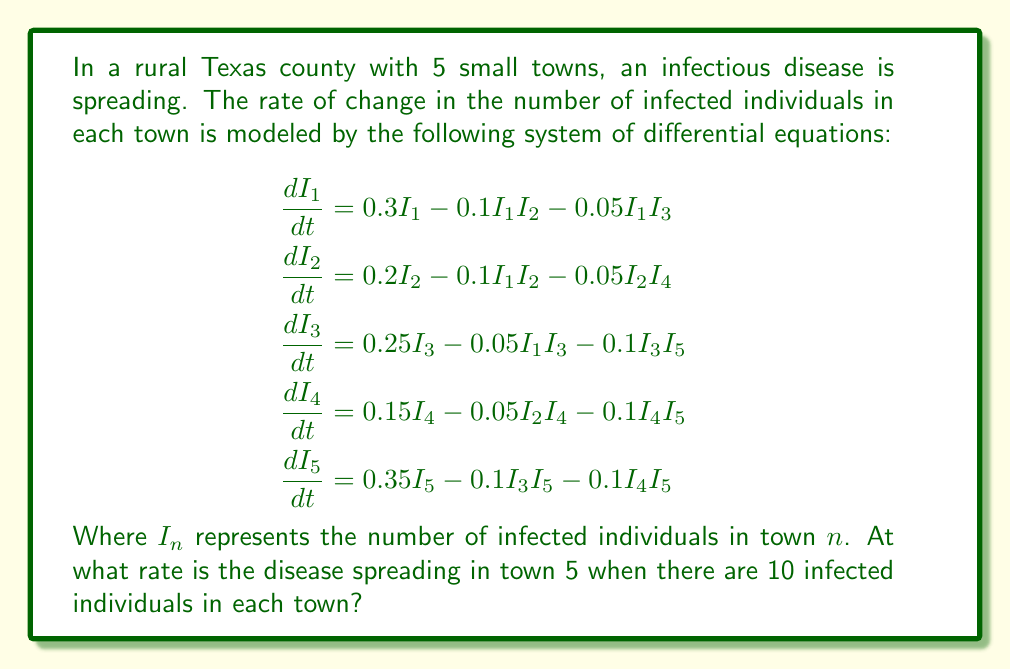Solve this math problem. To solve this problem, we need to follow these steps:

1) We're interested in the rate of change for town 5, so we'll focus on the equation for $\frac{dI_5}{dt}$.

2) The equation for town 5 is:
   $$\frac{dI_5}{dt} = 0.35I_5 - 0.1I_3I_5 - 0.1I_4I_5$$

3) We're told that there are 10 infected individuals in each town, so we can substitute $I_3 = I_4 = I_5 = 10$ into this equation:

   $$\frac{dI_5}{dt} = 0.35(10) - 0.1(10)(10) - 0.1(10)(10)$$

4) Now let's solve this step by step:
   
   $$\begin{aligned}
   \frac{dI_5}{dt} &= 3.5 - 10 - 10 \\
   &= 3.5 - 20 \\
   &= -16.5
   \end{aligned}$$

5) The negative value indicates that the number of infected individuals in town 5 is actually decreasing at a rate of 16.5 individuals per unit time.

This result shows that despite the initial growth term (0.35I_5), the interaction terms with other towns (-0.1I_3I_5 and -0.1I_4I_5) are strong enough to cause a net decrease in infections when all towns have equal numbers of infected individuals.
Answer: $-16.5$ individuals per unit time 